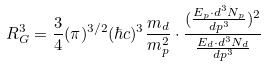<formula> <loc_0><loc_0><loc_500><loc_500>R _ { G } ^ { 3 } = \frac { 3 } { 4 } ( \pi ) ^ { 3 / 2 } ( \hbar { c } ) ^ { 3 } \frac { m _ { d } } { m _ { p } ^ { 2 } } \cdot \frac { ( \frac { E _ { p } \cdot d ^ { 3 } N _ { p } } { d p ^ { 3 } } ) ^ { 2 } } { \frac { E _ { d } \cdot d ^ { 3 } N _ { d } } { d p ^ { 3 } } }</formula> 